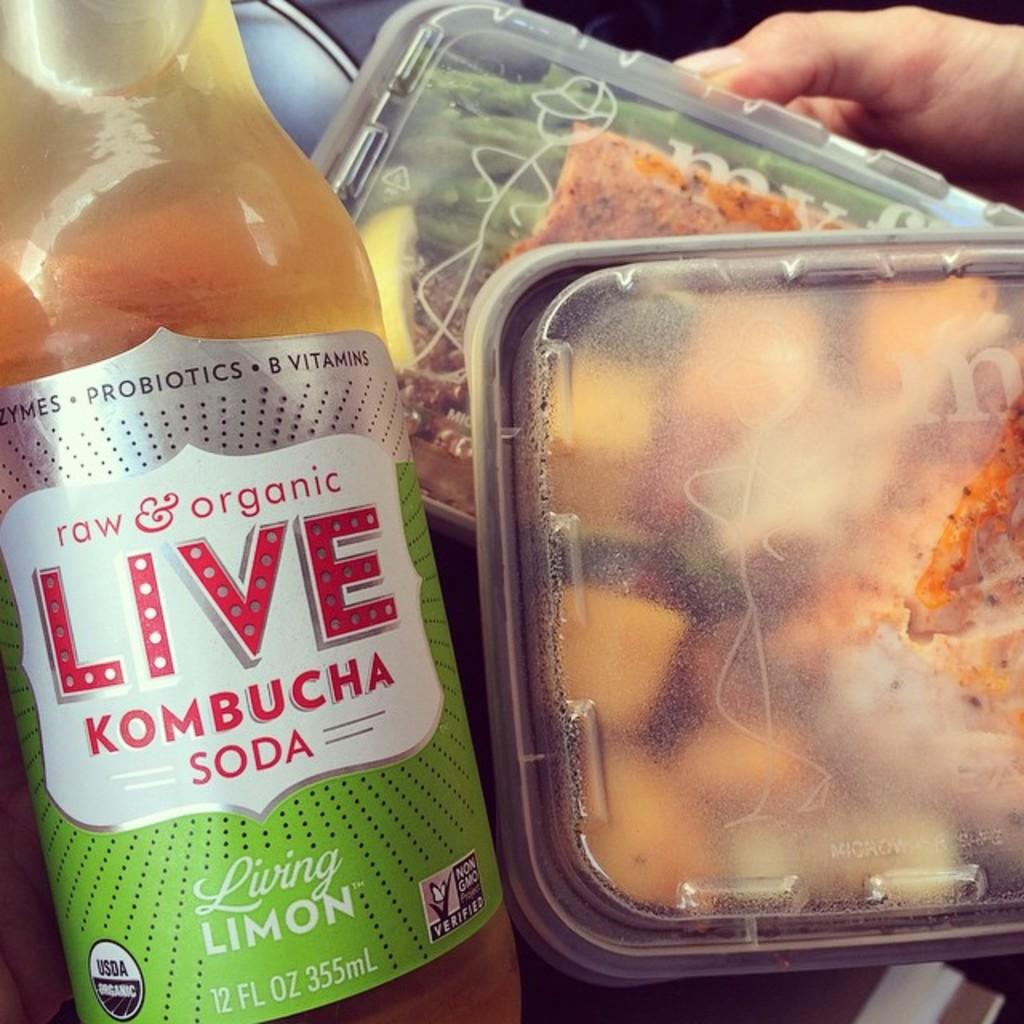<image>
Summarize the visual content of the image. Two meals in to go containers are held next to a bottle of Kombucha Soda. 